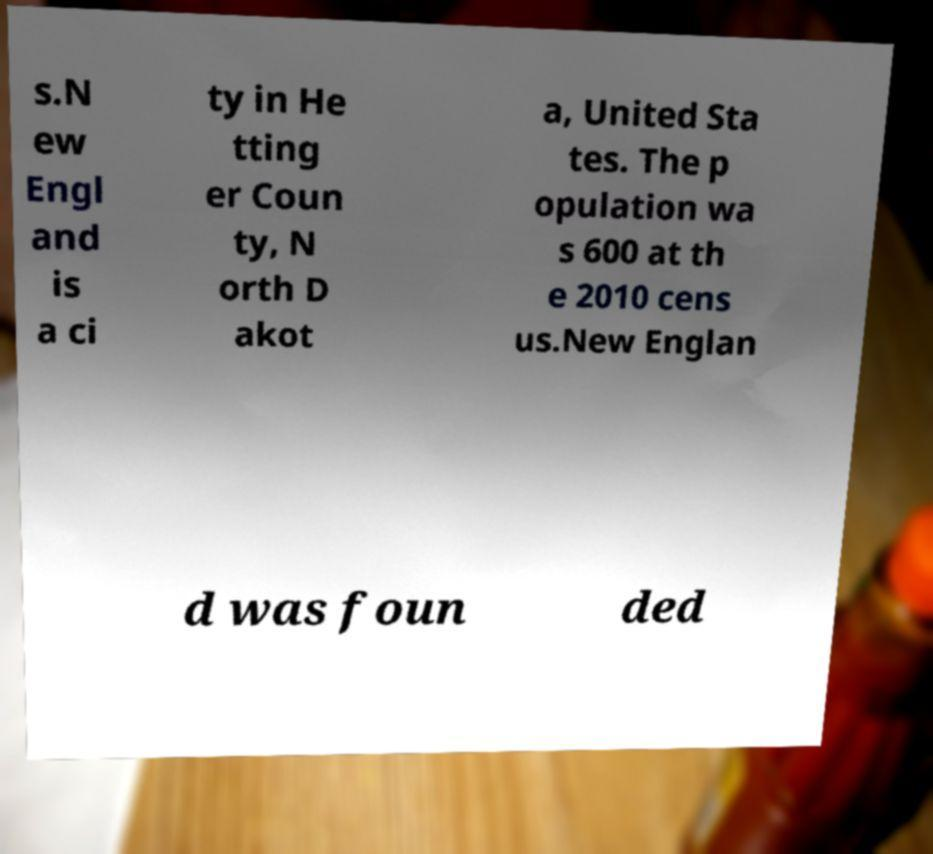I need the written content from this picture converted into text. Can you do that? s.N ew Engl and is a ci ty in He tting er Coun ty, N orth D akot a, United Sta tes. The p opulation wa s 600 at th e 2010 cens us.New Englan d was foun ded 